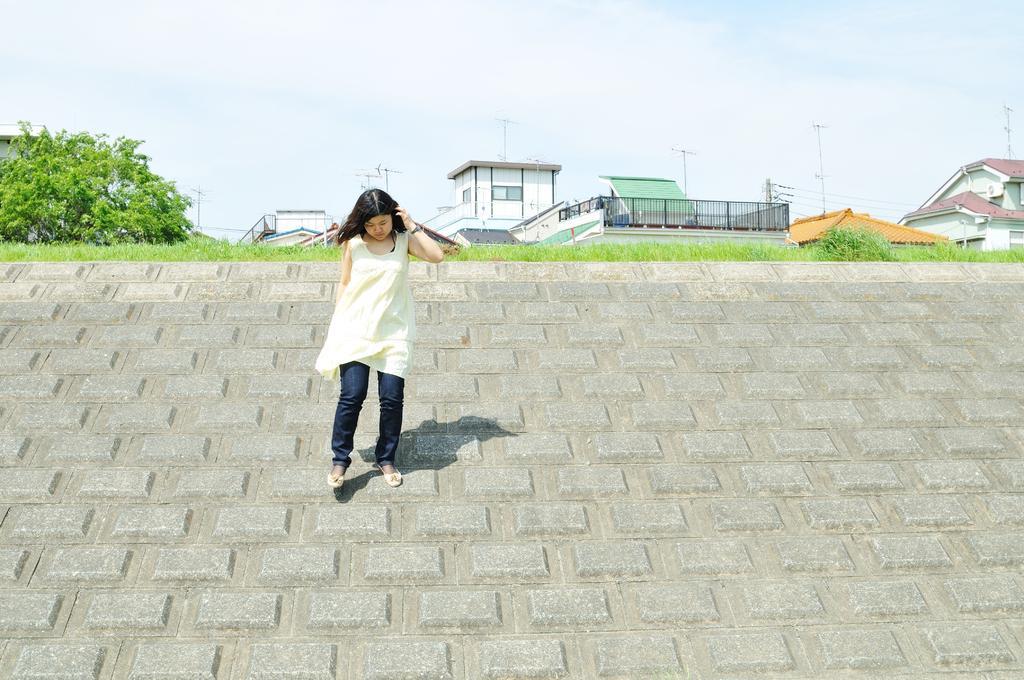In one or two sentences, can you explain what this image depicts? In this image in the center there is one women who is walking, at the bottom there is a floor and in the background there are some houses, trees, poles and some wires. On the top of the image there is sky. 